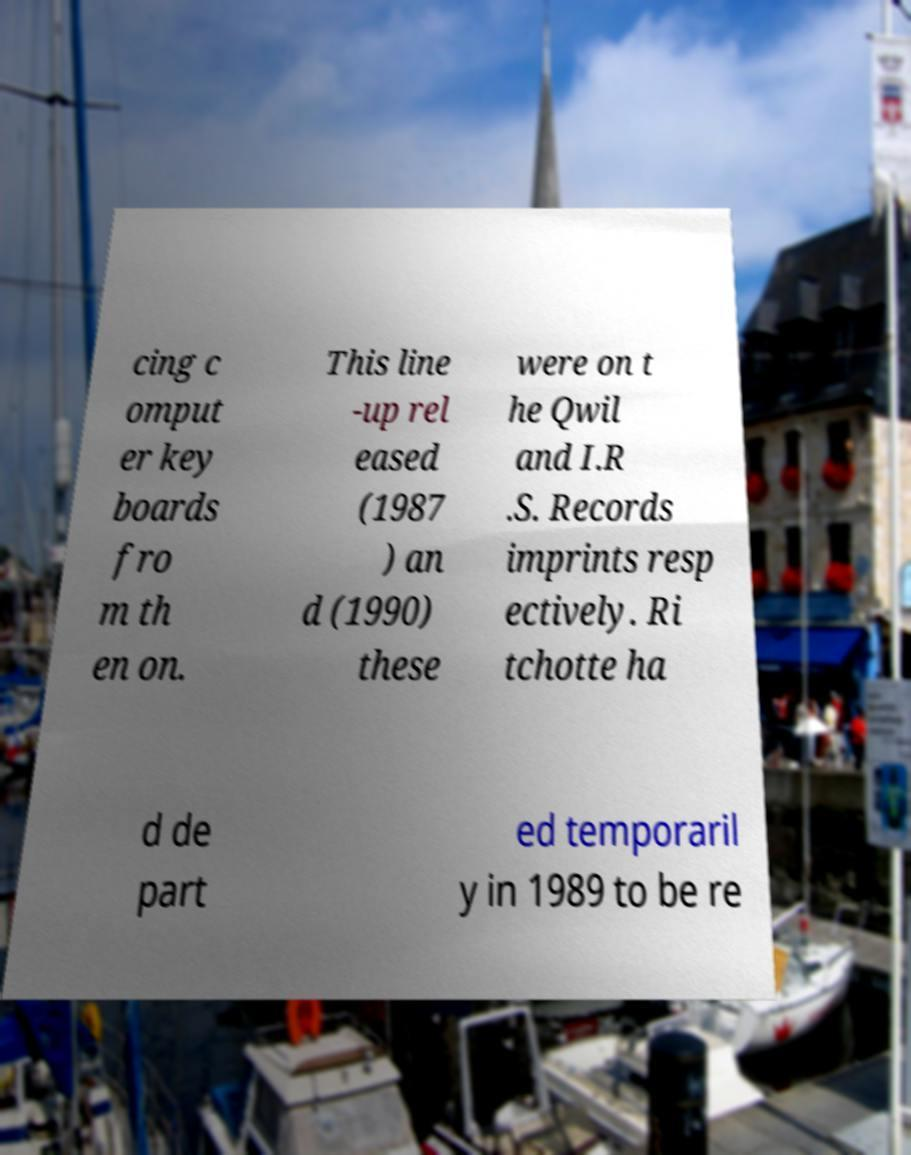Can you read and provide the text displayed in the image?This photo seems to have some interesting text. Can you extract and type it out for me? cing c omput er key boards fro m th en on. This line -up rel eased (1987 ) an d (1990) these were on t he Qwil and I.R .S. Records imprints resp ectively. Ri tchotte ha d de part ed temporaril y in 1989 to be re 